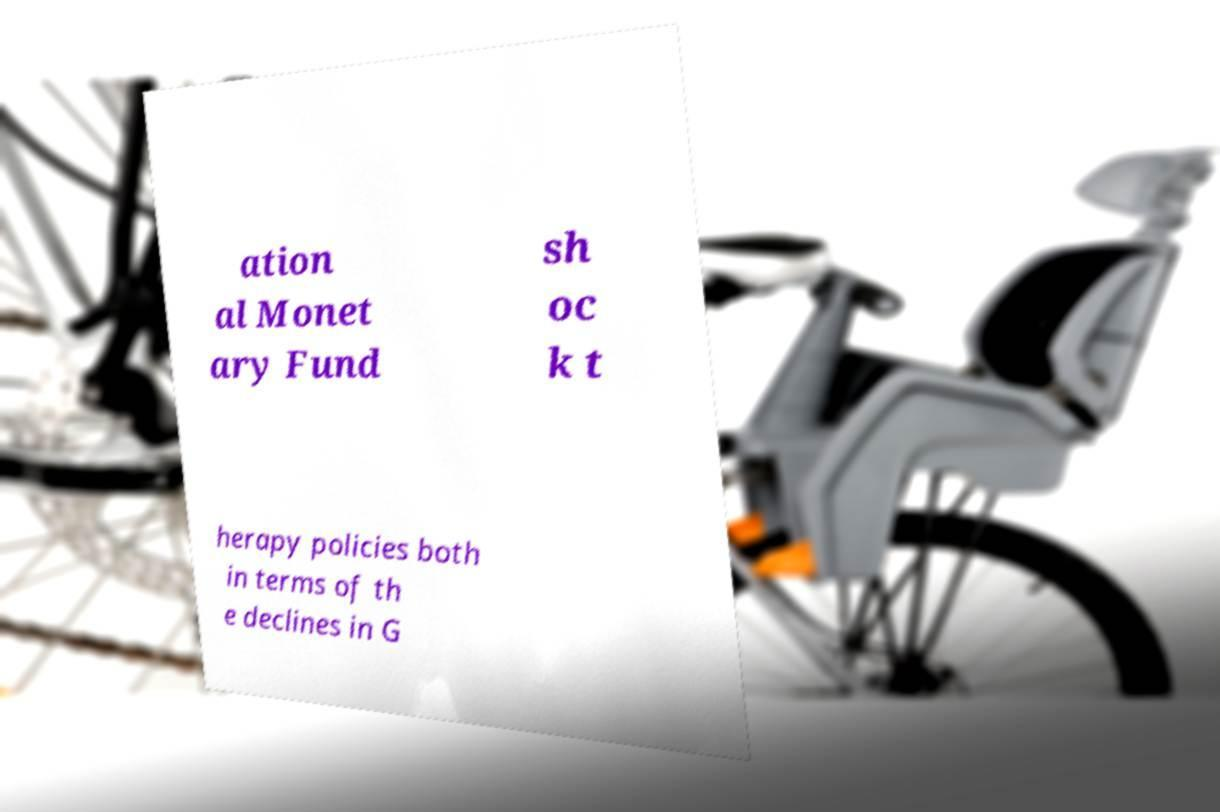Can you accurately transcribe the text from the provided image for me? ation al Monet ary Fund sh oc k t herapy policies both in terms of th e declines in G 